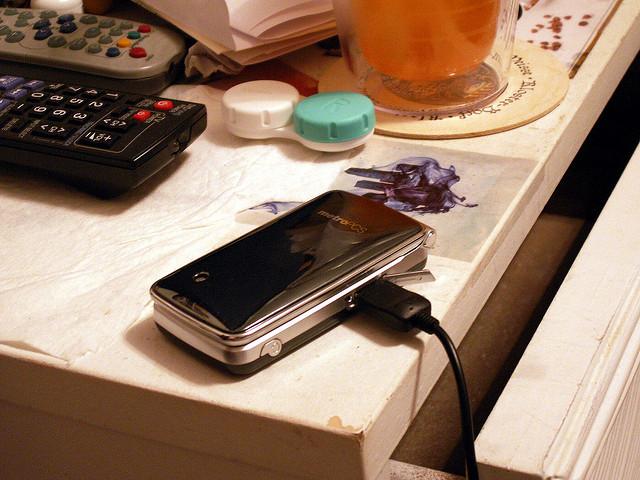What type of phone is on the night stand?
Quick response, please. Cell phone. What is in the green and white case?
Write a very short answer. Contacts. Do these belonging belong to someone who wears contacts?
Short answer required. Yes. 